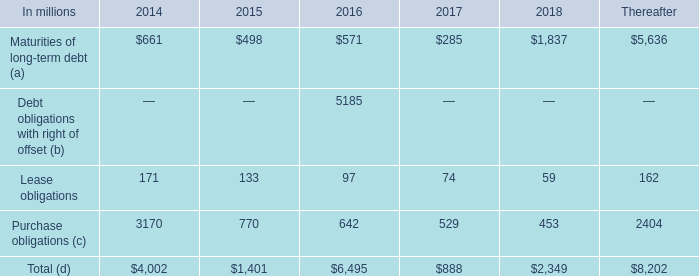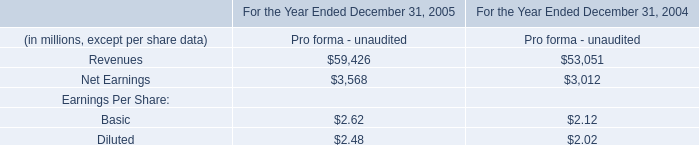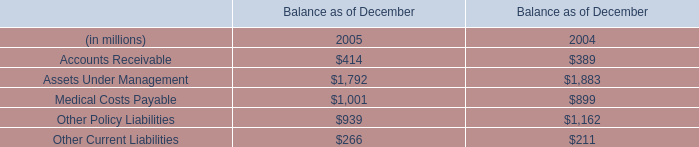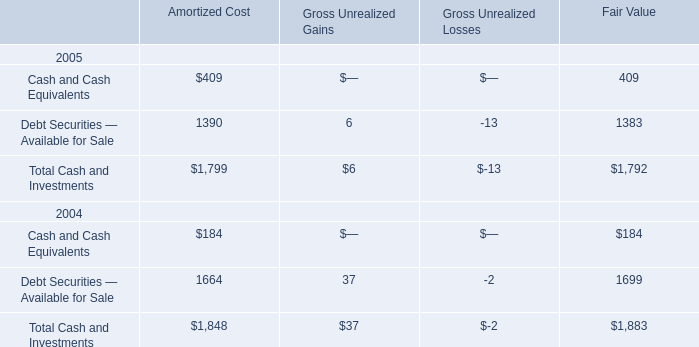What is the value of the Gross Unrealized Gains for the Total Cash and Investments in 2005? 
Answer: 6. 